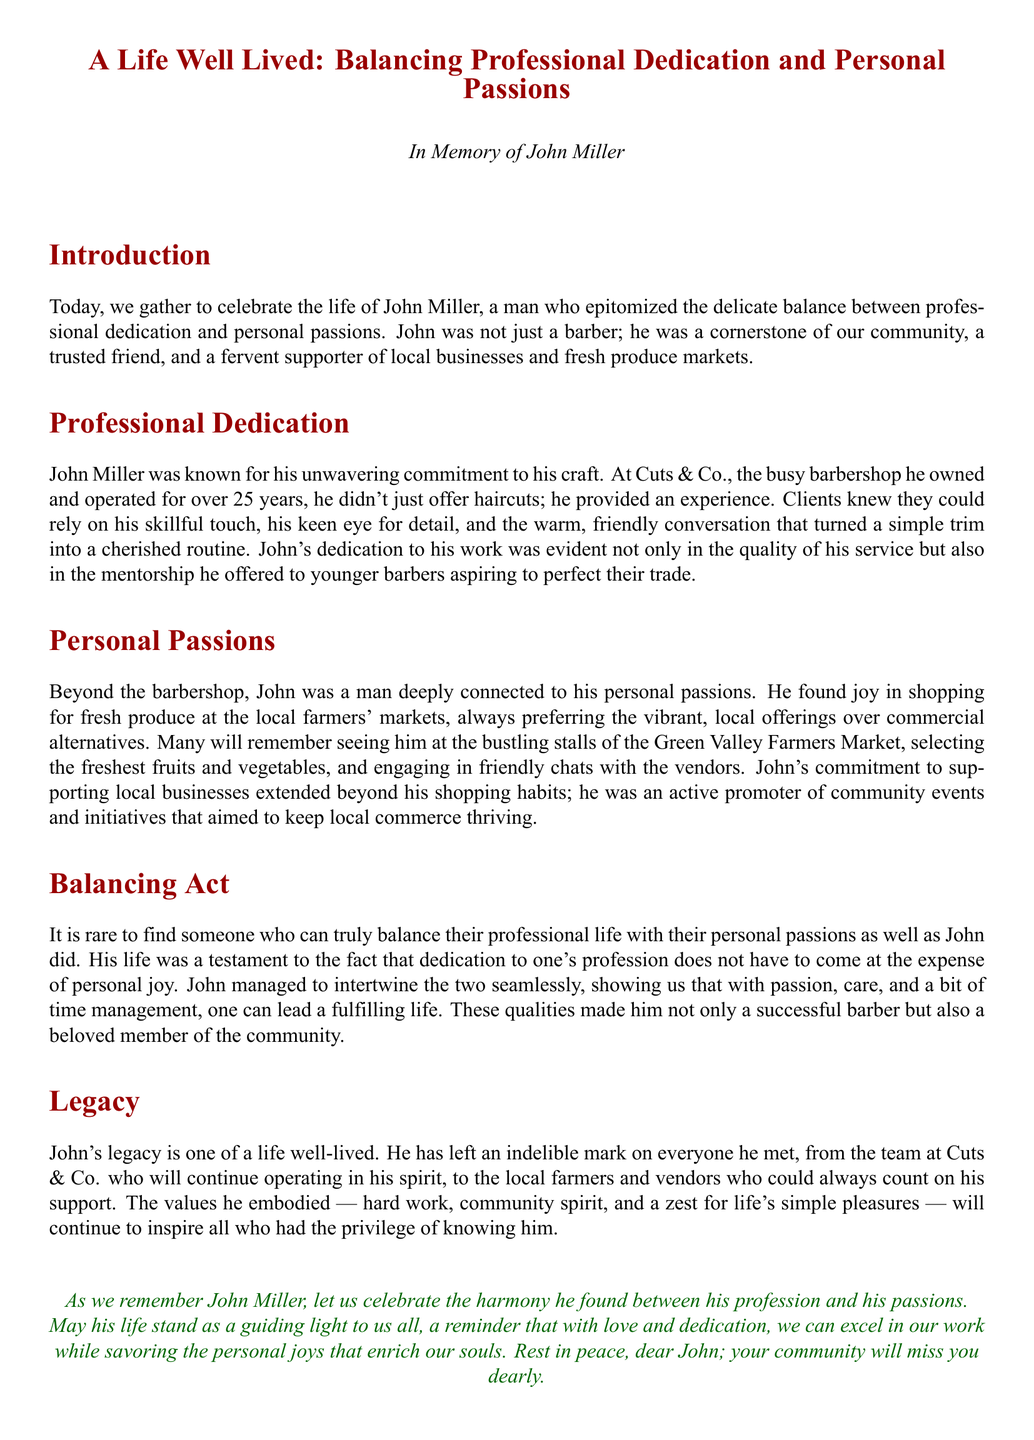What is the name of the person being remembered? The document introduces John Miller as the person being commemorated in the eulogy.
Answer: John Miller How many years did John operate his barbershop? The document states that John operated Cuts & Co. for over 25 years, indicating his long tenure in the profession.
Answer: 25 years What was John’s shop called? The eulogy mentions the barbershop's name as Cuts & Co.
Answer: Cuts & Co Where did John prefer to shop for fresh produce? The document identifies the Green Valley Farmers Market as John's chosen location for fresh produce shopping.
Answer: Green Valley Farmers Market What did John promote in addition to local businesses? The eulogy mentions that he actively promoted community events and initiatives.
Answer: Community events How did John engage with his clients at the barbershop? The document highlights that John provided not just haircuts but an experience characterized by warm, friendly conversation.
Answer: Warm, friendly conversation What qualities did John embody according to the document? The eulogy lists hard work, community spirit, and a zest for life's simple pleasures as qualities John embodied.
Answer: Hard work, community spirit, zest for life What is the overall theme of the eulogy? The document suggests that the theme revolves around the balance between professional dedication and personal passions in John's life.
Answer: Balance between professional dedication and personal passions What phrase is used to describe John’s legacy? The eulogy states that John's legacy is one of a life well-lived, indicating the positive impact he had on others.
Answer: A life well-lived 